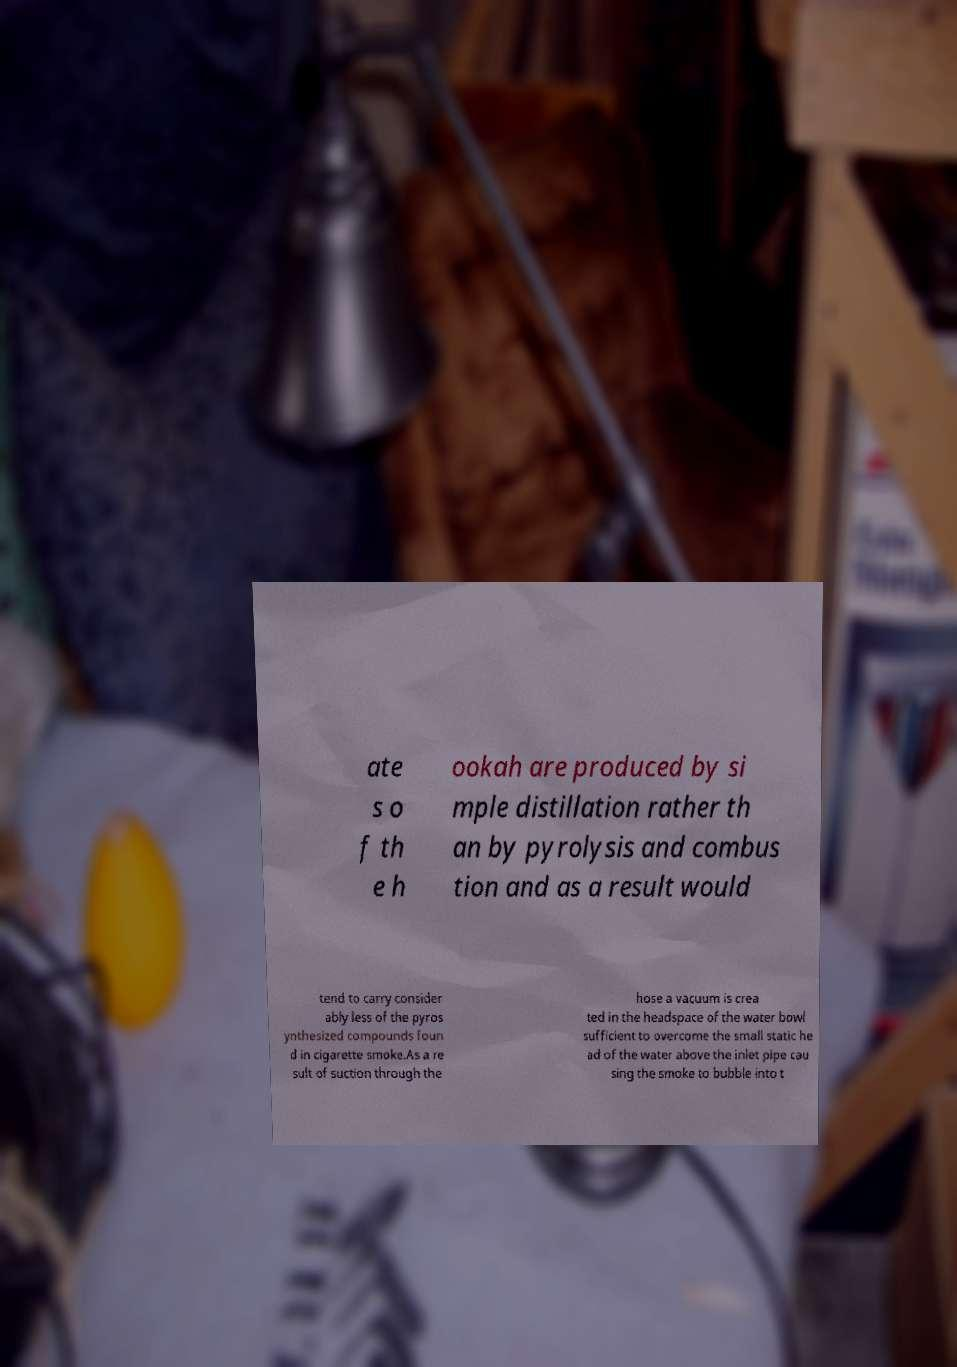Can you accurately transcribe the text from the provided image for me? ate s o f th e h ookah are produced by si mple distillation rather th an by pyrolysis and combus tion and as a result would tend to carry consider ably less of the pyros ynthesized compounds foun d in cigarette smoke.As a re sult of suction through the hose a vacuum is crea ted in the headspace of the water bowl sufficient to overcome the small static he ad of the water above the inlet pipe cau sing the smoke to bubble into t 